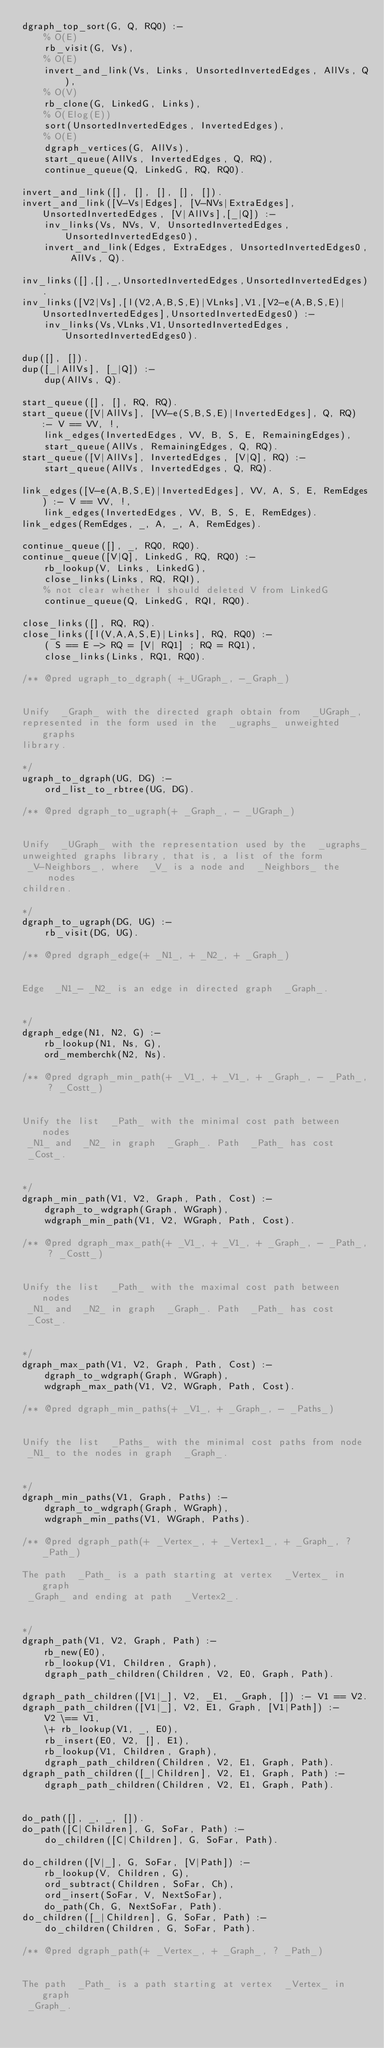Convert code to text. <code><loc_0><loc_0><loc_500><loc_500><_Prolog_>dgraph_top_sort(G, Q, RQ0) :-
	% O(E)
	rb_visit(G, Vs),
	% O(E)
	invert_and_link(Vs, Links, UnsortedInvertedEdges, AllVs, Q),
	% O(V)
	rb_clone(G, LinkedG, Links),
	% O(Elog(E))
	sort(UnsortedInvertedEdges, InvertedEdges),
	% O(E)
	dgraph_vertices(G, AllVs),
	start_queue(AllVs, InvertedEdges, Q, RQ),
	continue_queue(Q, LinkedG, RQ, RQ0).

invert_and_link([], [], [], [], []).
invert_and_link([V-Vs|Edges], [V-NVs|ExtraEdges], UnsortedInvertedEdges, [V|AllVs],[_|Q]) :-
	inv_links(Vs, NVs, V, UnsortedInvertedEdges, UnsortedInvertedEdges0),
	invert_and_link(Edges, ExtraEdges, UnsortedInvertedEdges0, AllVs, Q).

inv_links([],[],_,UnsortedInvertedEdges,UnsortedInvertedEdges).
inv_links([V2|Vs],[l(V2,A,B,S,E)|VLnks],V1,[V2-e(A,B,S,E)|UnsortedInvertedEdges],UnsortedInvertedEdges0) :-
	inv_links(Vs,VLnks,V1,UnsortedInvertedEdges,UnsortedInvertedEdges0).

dup([], []).
dup([_|AllVs], [_|Q]) :-
	dup(AllVs, Q).

start_queue([], [], RQ, RQ).
start_queue([V|AllVs], [VV-e(S,B,S,E)|InvertedEdges], Q, RQ) :- V == VV, !,
	link_edges(InvertedEdges, VV, B, S, E, RemainingEdges),
	start_queue(AllVs, RemainingEdges, Q, RQ).
start_queue([V|AllVs], InvertedEdges, [V|Q], RQ) :-
	start_queue(AllVs, InvertedEdges, Q, RQ).

link_edges([V-e(A,B,S,E)|InvertedEdges], VV, A, S, E, RemEdges) :- V == VV, !,
	link_edges(InvertedEdges, VV, B, S, E, RemEdges).
link_edges(RemEdges, _, A, _, A, RemEdges).

continue_queue([], _, RQ0, RQ0).
continue_queue([V|Q], LinkedG, RQ, RQ0) :-
	rb_lookup(V, Links, LinkedG),
	close_links(Links, RQ, RQI),
	% not clear whether I should deleted V from LinkedG
	continue_queue(Q, LinkedG, RQI, RQ0).

close_links([], RQ, RQ).
close_links([l(V,A,A,S,E)|Links], RQ, RQ0) :-
	( S == E -> RQ = [V| RQ1] ; RQ = RQ1),
	close_links(Links, RQ1, RQ0).

/** @pred ugraph_to_dgraph( +_UGraph_, -_Graph_) 


Unify  _Graph_ with the directed graph obtain from  _UGraph_,
represented in the form used in the  _ugraphs_ unweighted graphs
library.

*/
ugraph_to_dgraph(UG, DG) :-
	ord_list_to_rbtree(UG, DG).

/** @pred dgraph_to_ugraph(+ _Graph_, - _UGraph_) 


Unify  _UGraph_ with the representation used by the  _ugraphs_
unweighted graphs library, that is, a list of the form
 _V-Neighbors_, where  _V_ is a node and  _Neighbors_ the nodes
children.
 
*/
dgraph_to_ugraph(DG, UG) :-
	rb_visit(DG, UG).

/** @pred dgraph_edge(+ _N1_, + _N2_, + _Graph_) 


Edge  _N1_- _N2_ is an edge in directed graph  _Graph_.

 
*/
dgraph_edge(N1, N2, G) :-
	rb_lookup(N1, Ns, G),
	ord_memberchk(N2, Ns).

/** @pred dgraph_min_path(+ _V1_, + _V1_, + _Graph_, - _Path_, ? _Costt_) 


Unify the list  _Path_ with the minimal cost path between nodes
 _N1_ and  _N2_ in graph  _Graph_. Path  _Path_ has cost
 _Cost_.

 
*/
dgraph_min_path(V1, V2, Graph, Path, Cost) :-
	dgraph_to_wdgraph(Graph, WGraph),
	wdgraph_min_path(V1, V2, WGraph, Path, Cost).

/** @pred dgraph_max_path(+ _V1_, + _V1_, + _Graph_, - _Path_, ? _Costt_) 


Unify the list  _Path_ with the maximal cost path between nodes
 _N1_ and  _N2_ in graph  _Graph_. Path  _Path_ has cost
 _Cost_.

 
*/
dgraph_max_path(V1, V2, Graph, Path, Cost) :-
	dgraph_to_wdgraph(Graph, WGraph),
	wdgraph_max_path(V1, V2, WGraph, Path, Cost).

/** @pred dgraph_min_paths(+ _V1_, + _Graph_, - _Paths_) 


Unify the list  _Paths_ with the minimal cost paths from node
 _N1_ to the nodes in graph  _Graph_.

 
*/
dgraph_min_paths(V1, Graph, Paths) :-
	dgraph_to_wdgraph(Graph, WGraph),
	wdgraph_min_paths(V1, WGraph, Paths).

/** @pred dgraph_path(+ _Vertex_, + _Vertex1_, + _Graph_, ? _Path_)

The path  _Path_ is a path starting at vertex  _Vertex_ in graph
 _Graph_ and ending at path  _Vertex2_.

 
*/
dgraph_path(V1, V2, Graph, Path) :-
	rb_new(E0),
	rb_lookup(V1, Children, Graph),
	dgraph_path_children(Children, V2, E0, Graph, Path).

dgraph_path_children([V1|_], V2, _E1, _Graph, []) :- V1 == V2.
dgraph_path_children([V1|_], V2, E1, Graph, [V1|Path]) :-
	V2 \== V1,
	\+ rb_lookup(V1, _, E0),
	rb_insert(E0, V2, [], E1),
	rb_lookup(V1, Children, Graph),
	dgraph_path_children(Children, V2, E1, Graph, Path).
dgraph_path_children([_|Children], V2, E1, Graph, Path) :-
	dgraph_path_children(Children, V2, E1, Graph, Path).


do_path([], _, _, []).
do_path([C|Children], G, SoFar, Path) :-
	do_children([C|Children], G, SoFar, Path).

do_children([V|_], G, SoFar, [V|Path]) :-
	rb_lookup(V, Children, G),
	ord_subtract(Children, SoFar, Ch),
	ord_insert(SoFar, V, NextSoFar),
	do_path(Ch, G, NextSoFar, Path).
do_children([_|Children], G, SoFar, Path) :-
	do_children(Children, G, SoFar, Path).

/** @pred dgraph_path(+ _Vertex_, + _Graph_, ? _Path_) 


The path  _Path_ is a path starting at vertex  _Vertex_ in graph
 _Graph_.

 </code> 